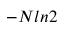<formula> <loc_0><loc_0><loc_500><loc_500>- N \ln 2</formula> 